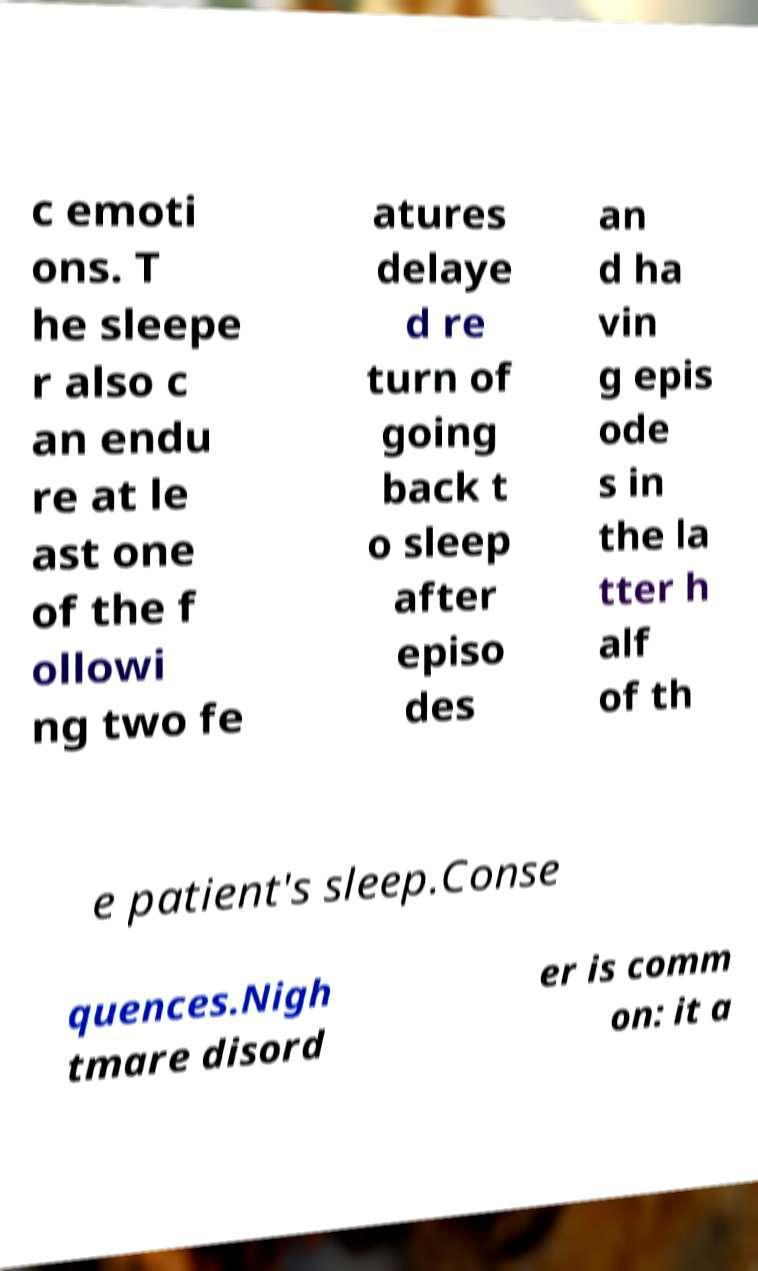For documentation purposes, I need the text within this image transcribed. Could you provide that? c emoti ons. T he sleepe r also c an endu re at le ast one of the f ollowi ng two fe atures delaye d re turn of going back t o sleep after episo des an d ha vin g epis ode s in the la tter h alf of th e patient's sleep.Conse quences.Nigh tmare disord er is comm on: it a 